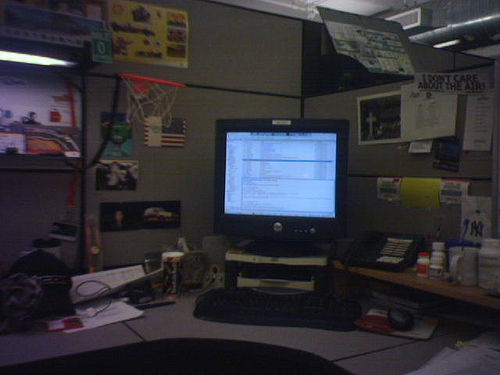Describe the objects in this image and their specific colors. I can see tv in black and lightblue tones, keyboard in black, navy, and maroon tones, cup in black and gray tones, cup in black, maroon, and gray tones, and bottle in black, gray, and darkgreen tones in this image. 